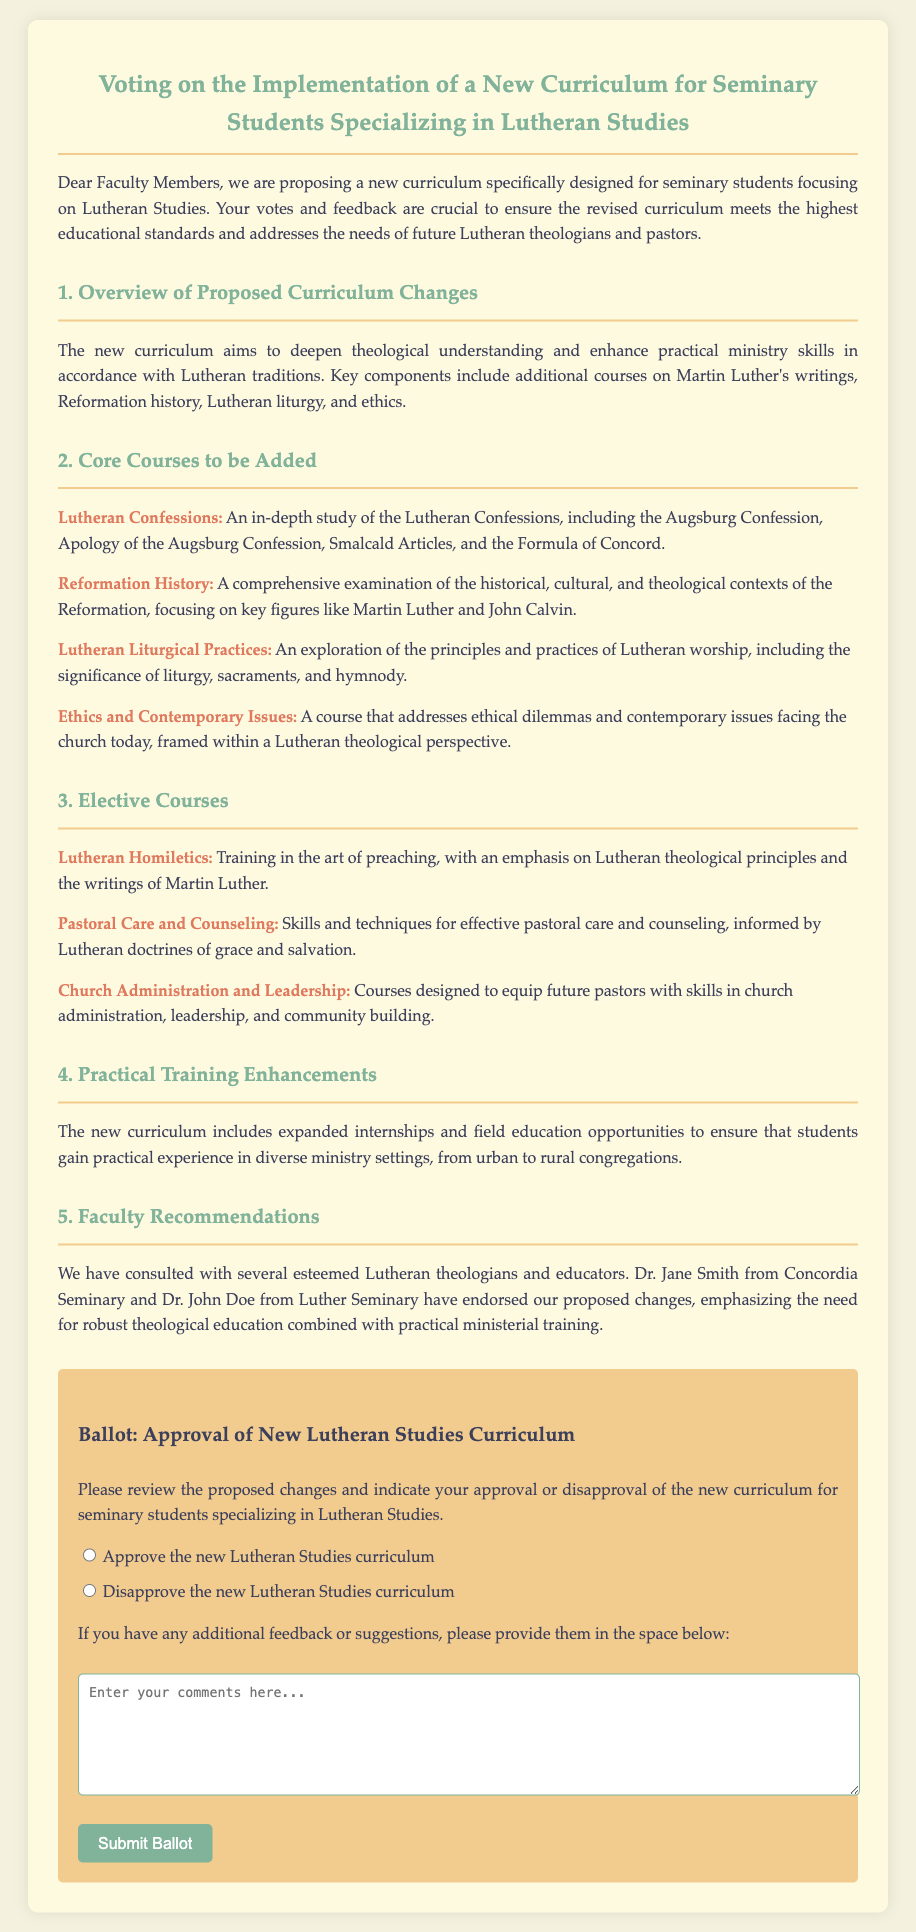What is the title of the document? The title of the document is mentioned at the top of the ballot.
Answer: Voting on the Implementation of a New Curriculum for Seminary Students Specializing in Lutheran Studies Which course focuses on Martin Luther's writings? The document lists several core and elective courses, with one specifically focusing on preaching.
Answer: Lutheran Homiletics How many core courses are listed in the document? The document has a section titled "Core Courses to be Added" which outlines the number of core courses.
Answer: Four Who endorsed the proposed changes? The document mentions two individuals who supported the new curriculum proposals.
Answer: Dr. Jane Smith and Dr. John Doe What is the purpose of expanded internships mentioned in the document? The purpose of expanded internships is to provide students with practical experience in various ministry settings.
Answer: Practical experience What options are provided for voting on the new curriculum? The ballot section clearly lays out the two choices available for voting regarding the new curriculum.
Answer: Approve or Disapprove What major area does the curriculum aim to address? The document emphasizes a core focus on enhancing practical ministry skills and theological understanding.
Answer: Practical ministry skills What type of document is this? The structure and content outline indicate that it is a voting tool used for gauging opinions on curriculum changes.
Answer: Ballot 